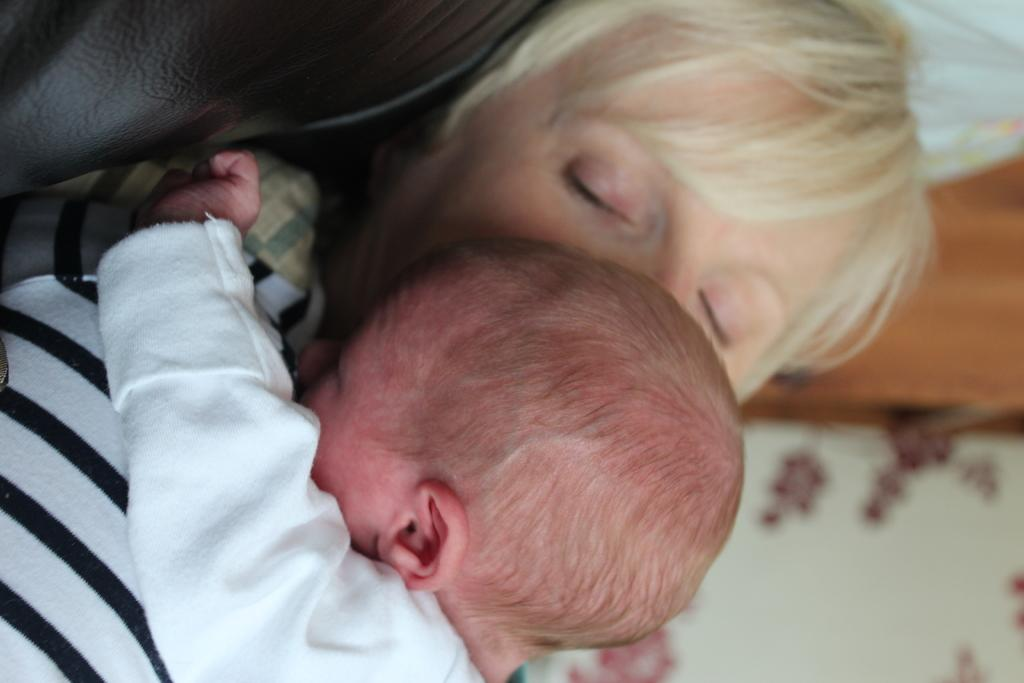Who is present in the image? There is a person and a baby in the image. What are the people in the image wearing? The person and the baby are both wearing clothes. Can you describe the background of the image? The background of the image is blurred. What is the reaction of the government to the situation in the image? There is no indication of a government or any specific situation in the image, so it is not possible to determine the government's reaction. 